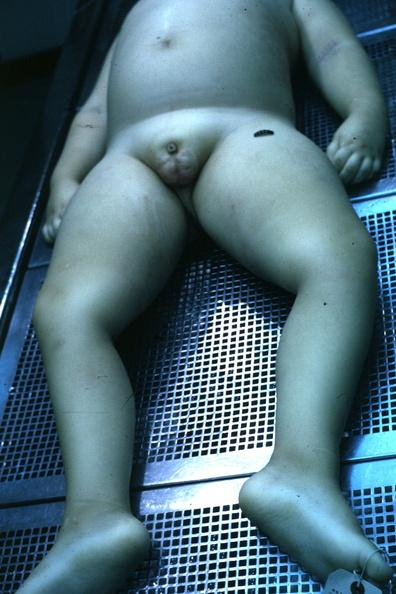s penis, testicles present?
Answer the question using a single word or phrase. Yes 